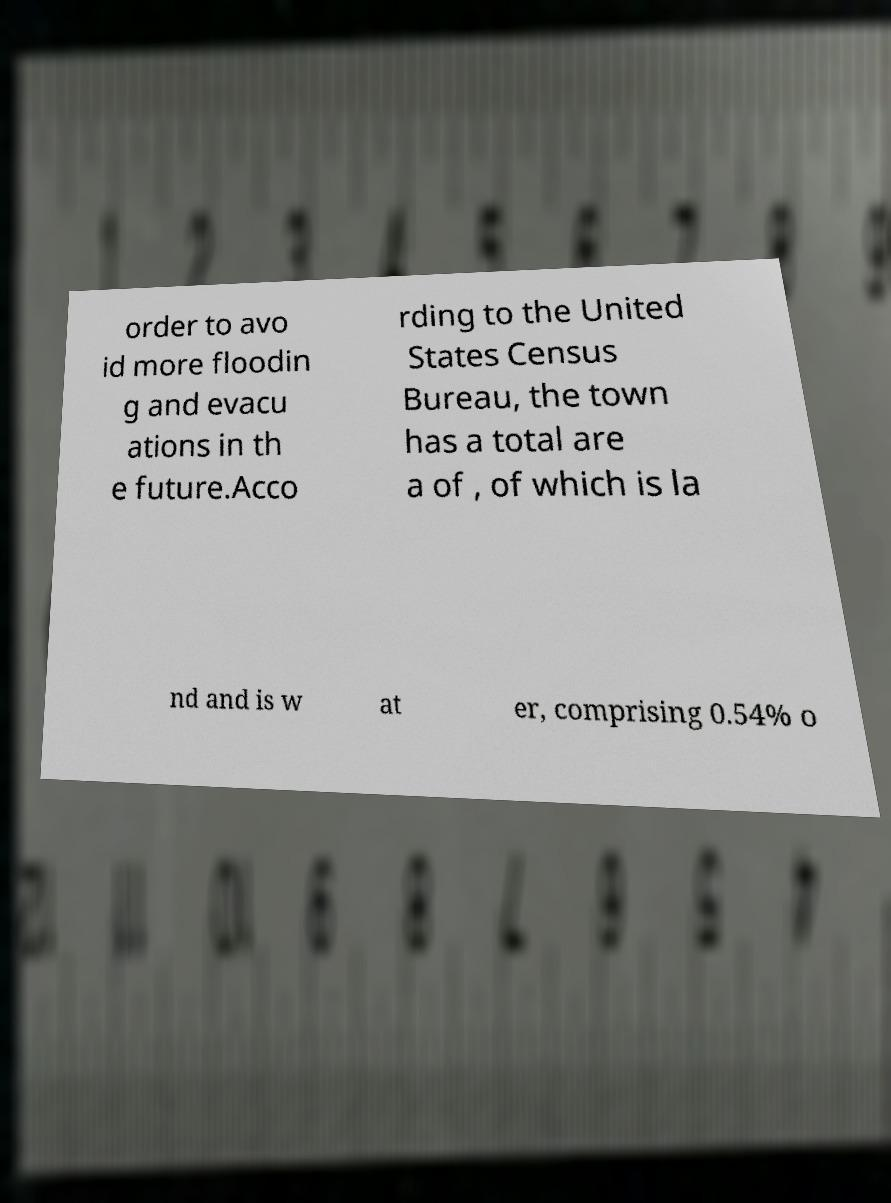Could you assist in decoding the text presented in this image and type it out clearly? order to avo id more floodin g and evacu ations in th e future.Acco rding to the United States Census Bureau, the town has a total are a of , of which is la nd and is w at er, comprising 0.54% o 